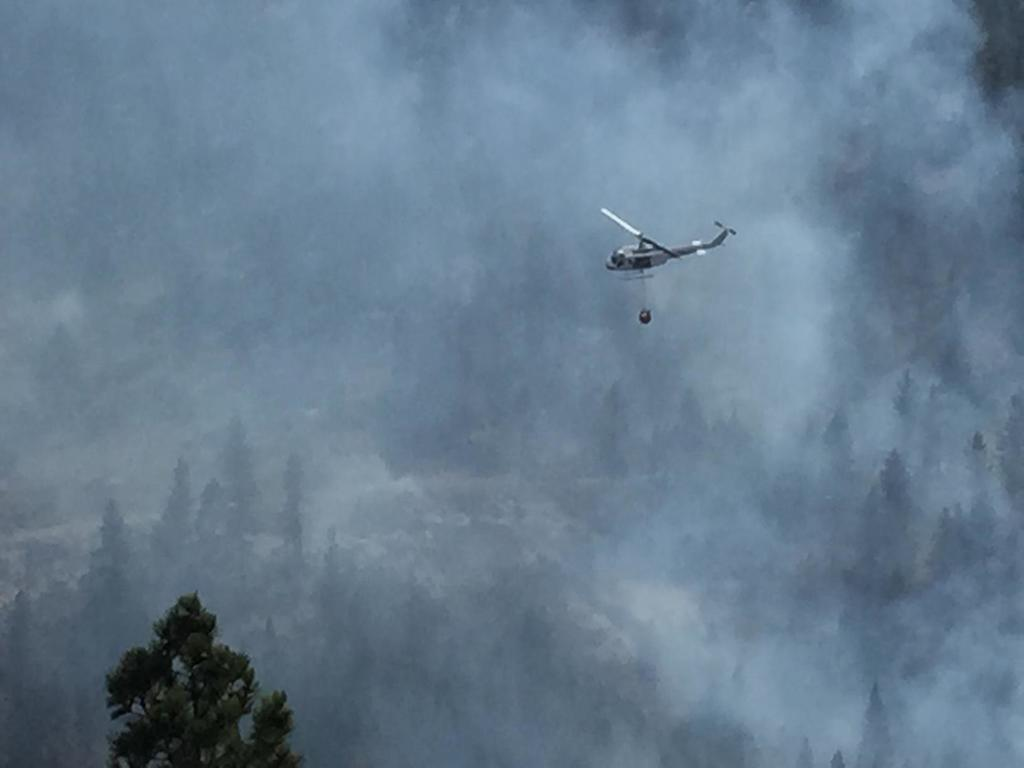What is located on the right side of the image? There is a helicopter on the right side of the image. What can be seen in the background of the image? There are trees in the background of the image. What is visible at the top of the image? The sky is visible at the top of the image. Where is the crown placed in the image? There is no crown present in the image. What type of rail can be seen supporting the helicopter in the image? There is no rail visible in the image; the helicopter is not supported by any rail. 